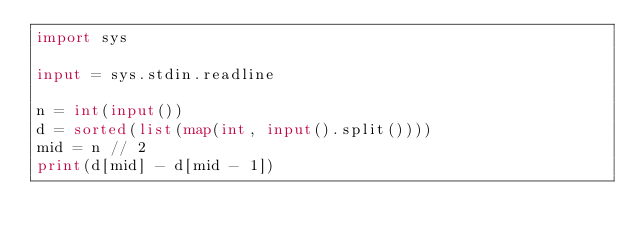Convert code to text. <code><loc_0><loc_0><loc_500><loc_500><_Python_>import sys

input = sys.stdin.readline

n = int(input())
d = sorted(list(map(int, input().split())))
mid = n // 2
print(d[mid] - d[mid - 1])
</code> 